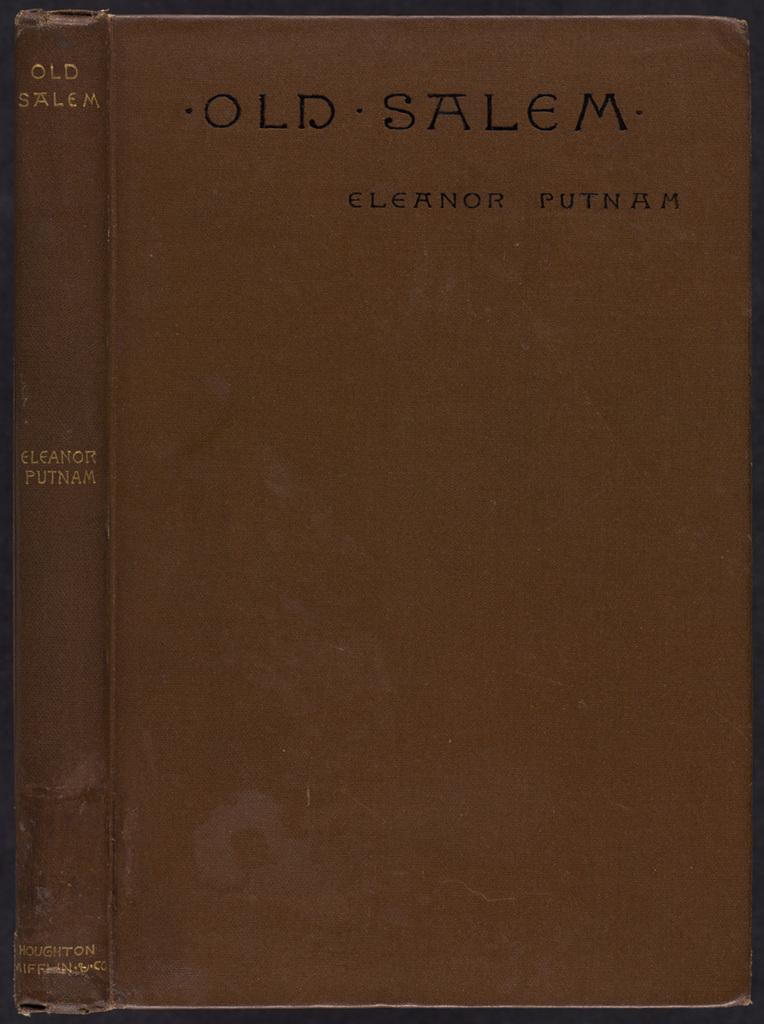<image>
Write a terse but informative summary of the picture. Brown book titled Old Salem by Eleanor Putnam. 